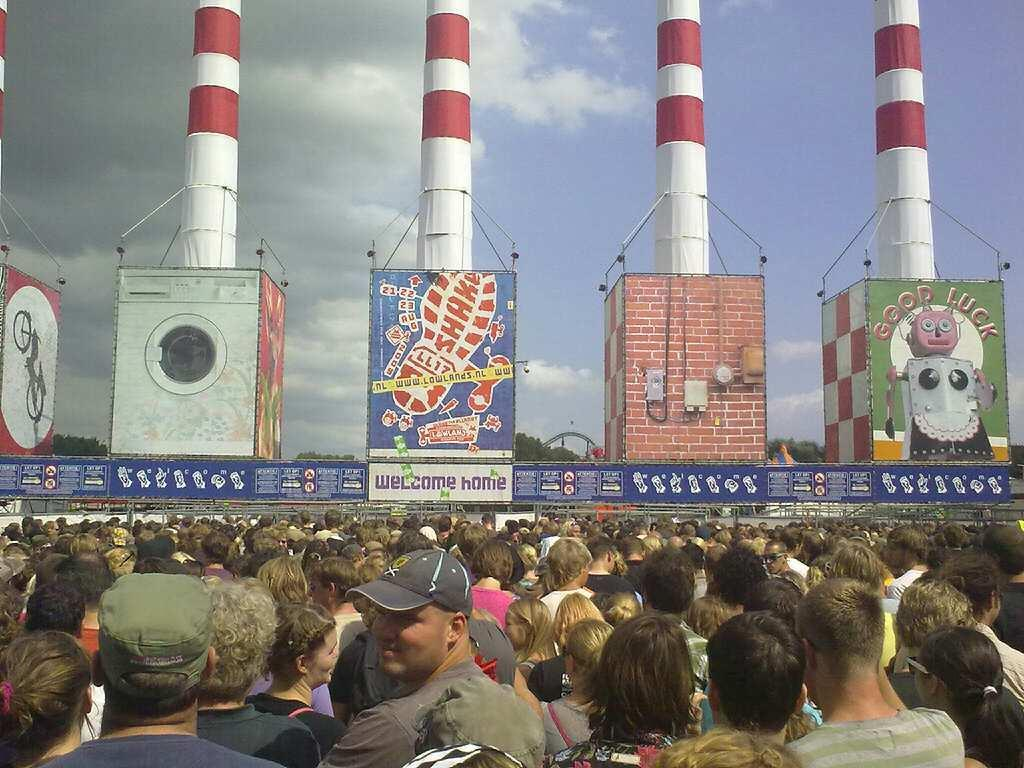Who or what can be seen in the image? There are people in the image. What structures are present in the image? There are hoardings and pillars in the image. What type of natural elements can be seen in the image? There are trees visible in the image. What is visible in the sky in the image? There are clouds in the sky in the image. What type of silk fabric is draped over the window in the image? There is no silk fabric or window present in the image. What type of party is being held in the image? There is no party or indication of a party in the image. 